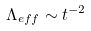Convert formula to latex. <formula><loc_0><loc_0><loc_500><loc_500>\Lambda _ { e f f } \sim t ^ { - 2 }</formula> 